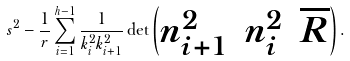<formula> <loc_0><loc_0><loc_500><loc_500>s ^ { 2 } - \frac { 1 } { r } \sum _ { i = 1 } ^ { h - 1 } \frac { 1 } { k ^ { 2 } _ { i } k ^ { 2 } _ { i + 1 } } \det \begin{pmatrix} n ^ { 2 } _ { i + 1 } & n ^ { 2 } _ { i } & \overline { R } \end{pmatrix} .</formula> 